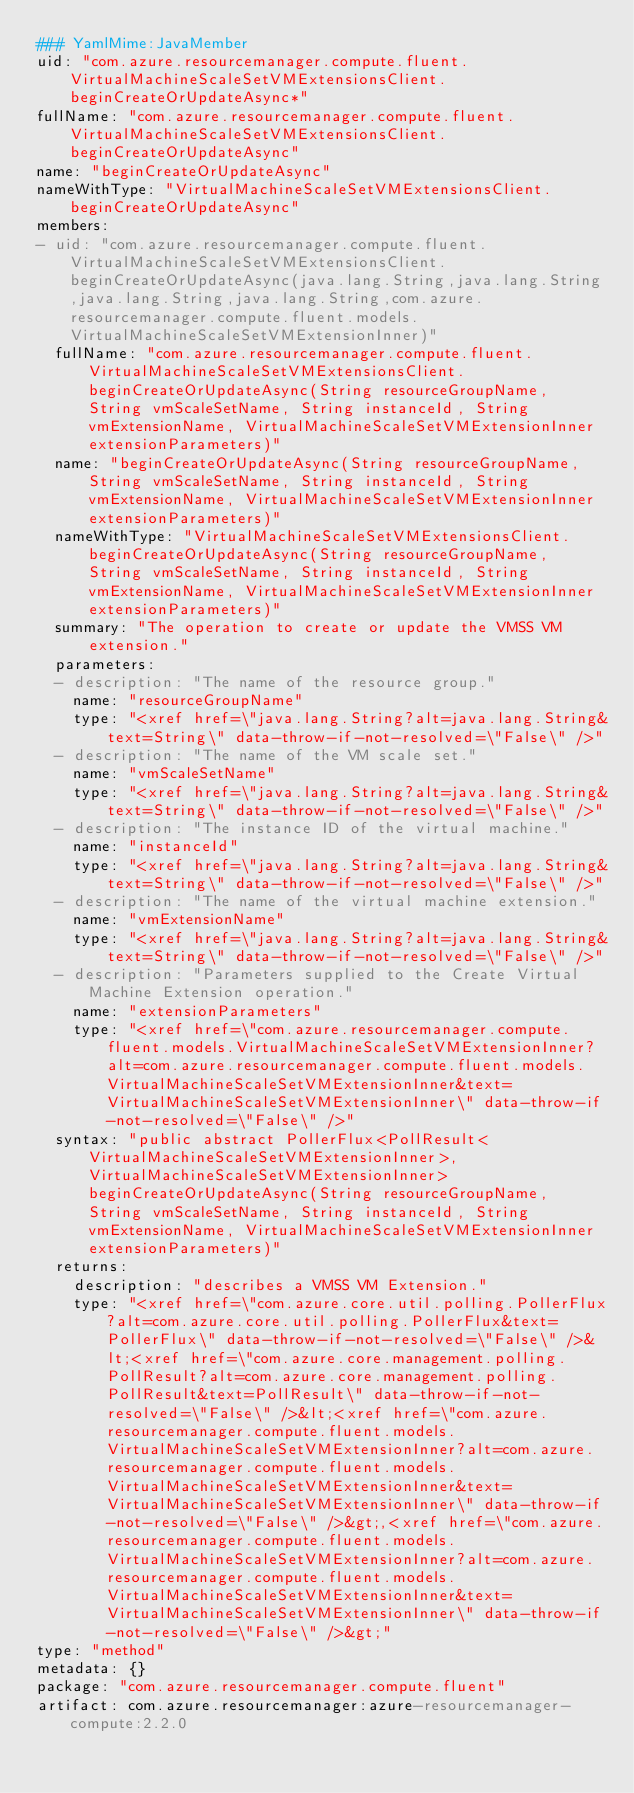Convert code to text. <code><loc_0><loc_0><loc_500><loc_500><_YAML_>### YamlMime:JavaMember
uid: "com.azure.resourcemanager.compute.fluent.VirtualMachineScaleSetVMExtensionsClient.beginCreateOrUpdateAsync*"
fullName: "com.azure.resourcemanager.compute.fluent.VirtualMachineScaleSetVMExtensionsClient.beginCreateOrUpdateAsync"
name: "beginCreateOrUpdateAsync"
nameWithType: "VirtualMachineScaleSetVMExtensionsClient.beginCreateOrUpdateAsync"
members:
- uid: "com.azure.resourcemanager.compute.fluent.VirtualMachineScaleSetVMExtensionsClient.beginCreateOrUpdateAsync(java.lang.String,java.lang.String,java.lang.String,java.lang.String,com.azure.resourcemanager.compute.fluent.models.VirtualMachineScaleSetVMExtensionInner)"
  fullName: "com.azure.resourcemanager.compute.fluent.VirtualMachineScaleSetVMExtensionsClient.beginCreateOrUpdateAsync(String resourceGroupName, String vmScaleSetName, String instanceId, String vmExtensionName, VirtualMachineScaleSetVMExtensionInner extensionParameters)"
  name: "beginCreateOrUpdateAsync(String resourceGroupName, String vmScaleSetName, String instanceId, String vmExtensionName, VirtualMachineScaleSetVMExtensionInner extensionParameters)"
  nameWithType: "VirtualMachineScaleSetVMExtensionsClient.beginCreateOrUpdateAsync(String resourceGroupName, String vmScaleSetName, String instanceId, String vmExtensionName, VirtualMachineScaleSetVMExtensionInner extensionParameters)"
  summary: "The operation to create or update the VMSS VM extension."
  parameters:
  - description: "The name of the resource group."
    name: "resourceGroupName"
    type: "<xref href=\"java.lang.String?alt=java.lang.String&text=String\" data-throw-if-not-resolved=\"False\" />"
  - description: "The name of the VM scale set."
    name: "vmScaleSetName"
    type: "<xref href=\"java.lang.String?alt=java.lang.String&text=String\" data-throw-if-not-resolved=\"False\" />"
  - description: "The instance ID of the virtual machine."
    name: "instanceId"
    type: "<xref href=\"java.lang.String?alt=java.lang.String&text=String\" data-throw-if-not-resolved=\"False\" />"
  - description: "The name of the virtual machine extension."
    name: "vmExtensionName"
    type: "<xref href=\"java.lang.String?alt=java.lang.String&text=String\" data-throw-if-not-resolved=\"False\" />"
  - description: "Parameters supplied to the Create Virtual Machine Extension operation."
    name: "extensionParameters"
    type: "<xref href=\"com.azure.resourcemanager.compute.fluent.models.VirtualMachineScaleSetVMExtensionInner?alt=com.azure.resourcemanager.compute.fluent.models.VirtualMachineScaleSetVMExtensionInner&text=VirtualMachineScaleSetVMExtensionInner\" data-throw-if-not-resolved=\"False\" />"
  syntax: "public abstract PollerFlux<PollResult<VirtualMachineScaleSetVMExtensionInner>,VirtualMachineScaleSetVMExtensionInner> beginCreateOrUpdateAsync(String resourceGroupName, String vmScaleSetName, String instanceId, String vmExtensionName, VirtualMachineScaleSetVMExtensionInner extensionParameters)"
  returns:
    description: "describes a VMSS VM Extension."
    type: "<xref href=\"com.azure.core.util.polling.PollerFlux?alt=com.azure.core.util.polling.PollerFlux&text=PollerFlux\" data-throw-if-not-resolved=\"False\" />&lt;<xref href=\"com.azure.core.management.polling.PollResult?alt=com.azure.core.management.polling.PollResult&text=PollResult\" data-throw-if-not-resolved=\"False\" />&lt;<xref href=\"com.azure.resourcemanager.compute.fluent.models.VirtualMachineScaleSetVMExtensionInner?alt=com.azure.resourcemanager.compute.fluent.models.VirtualMachineScaleSetVMExtensionInner&text=VirtualMachineScaleSetVMExtensionInner\" data-throw-if-not-resolved=\"False\" />&gt;,<xref href=\"com.azure.resourcemanager.compute.fluent.models.VirtualMachineScaleSetVMExtensionInner?alt=com.azure.resourcemanager.compute.fluent.models.VirtualMachineScaleSetVMExtensionInner&text=VirtualMachineScaleSetVMExtensionInner\" data-throw-if-not-resolved=\"False\" />&gt;"
type: "method"
metadata: {}
package: "com.azure.resourcemanager.compute.fluent"
artifact: com.azure.resourcemanager:azure-resourcemanager-compute:2.2.0
</code> 